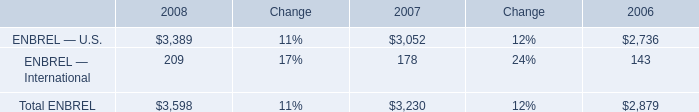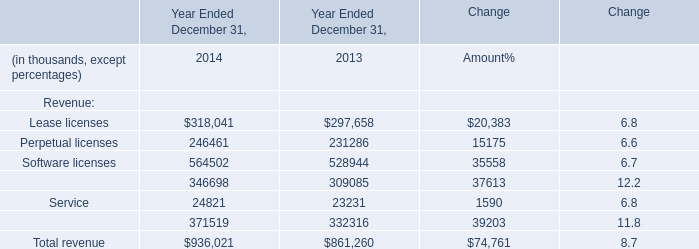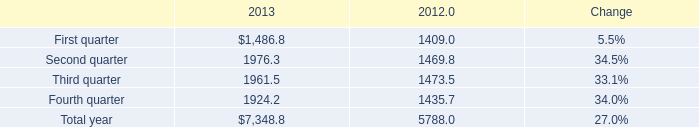what's the total amount of ENBREL — U.S. of 2008, and Third quarter of 2012 ? 
Computations: (3389.0 + 1473.5)
Answer: 4862.5. 